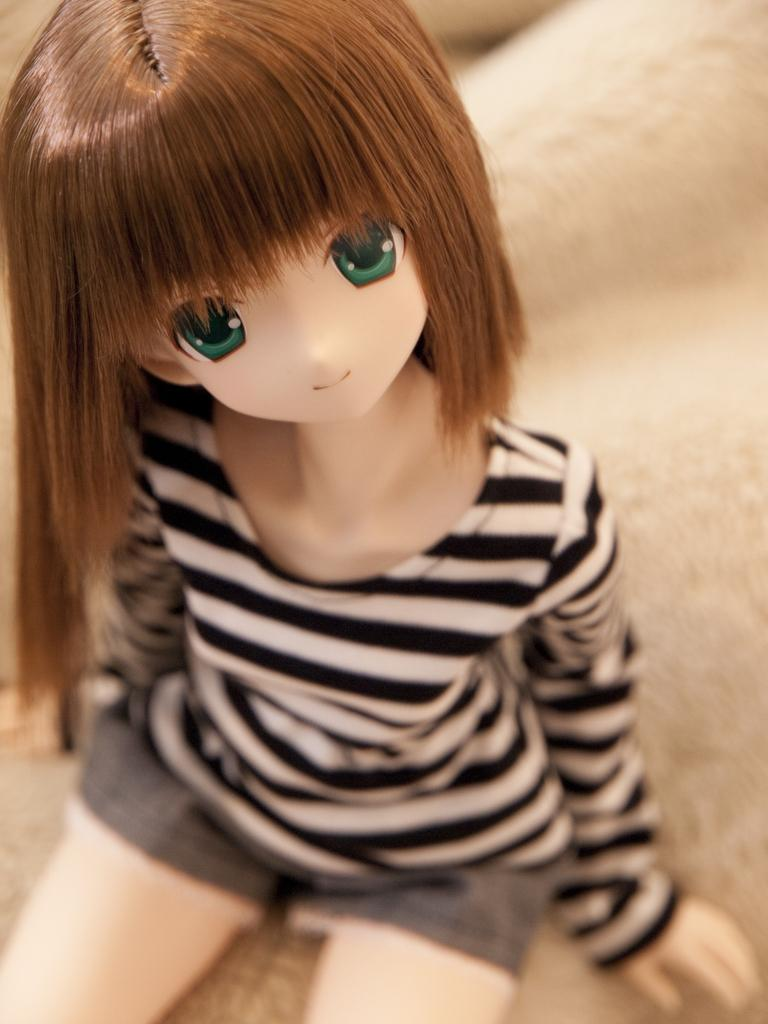What is the main subject in the image? There is a doll in the image. Can you describe the doll's position or location in the image? The doll is on an object. What type of watch is the doll wearing in the image? There is no watch present in the image, as the doll is not wearing any accessories. 